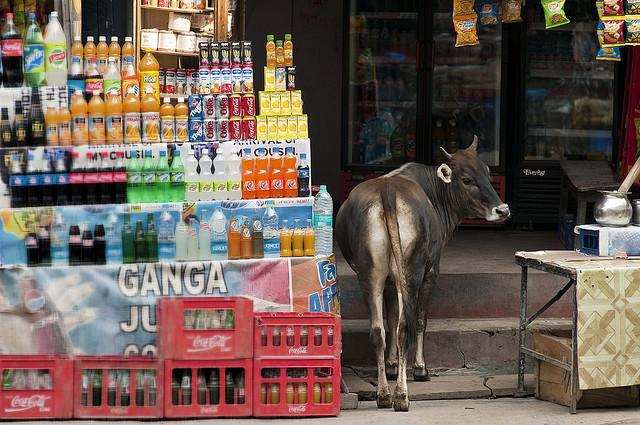The first five letters in white that are on the sign are used in spelling what style? Please explain your reasoning. gangnam. That word starts with those letters. 